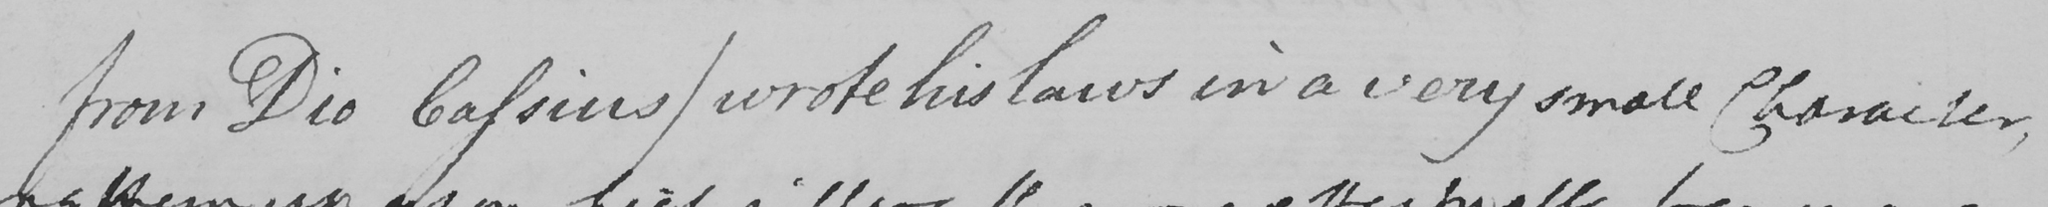Can you read and transcribe this handwriting? from Dio Cassius )  wrote his laws in a very small Character , 